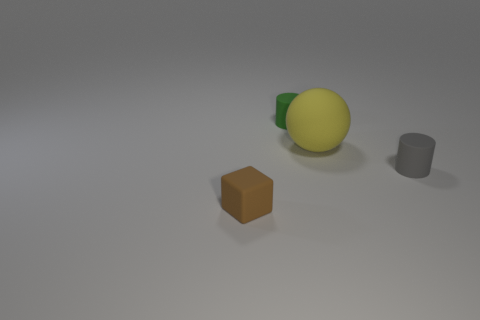What number of spheres are either small green rubber things or rubber objects?
Ensure brevity in your answer.  1. What is the size of the cylinder that is in front of the small matte cylinder that is to the left of the small cylinder in front of the small green cylinder?
Provide a short and direct response. Small. The brown rubber object that is the same size as the gray matte cylinder is what shape?
Provide a short and direct response. Cube. What is the shape of the brown matte object?
Keep it short and to the point. Cube. Is the material of the small object that is to the left of the tiny green object the same as the big yellow ball?
Offer a very short reply. Yes. How big is the matte cylinder that is left of the rubber cylinder right of the big yellow object?
Offer a very short reply. Small. What color is the rubber object that is on the right side of the green rubber cylinder and in front of the yellow rubber ball?
Your answer should be very brief. Gray. What material is the green object that is the same size as the gray cylinder?
Give a very brief answer. Rubber. What number of other objects are there of the same material as the large yellow object?
Offer a very short reply. 3. Do the small matte cylinder in front of the tiny green matte object and the block in front of the matte sphere have the same color?
Ensure brevity in your answer.  No. 